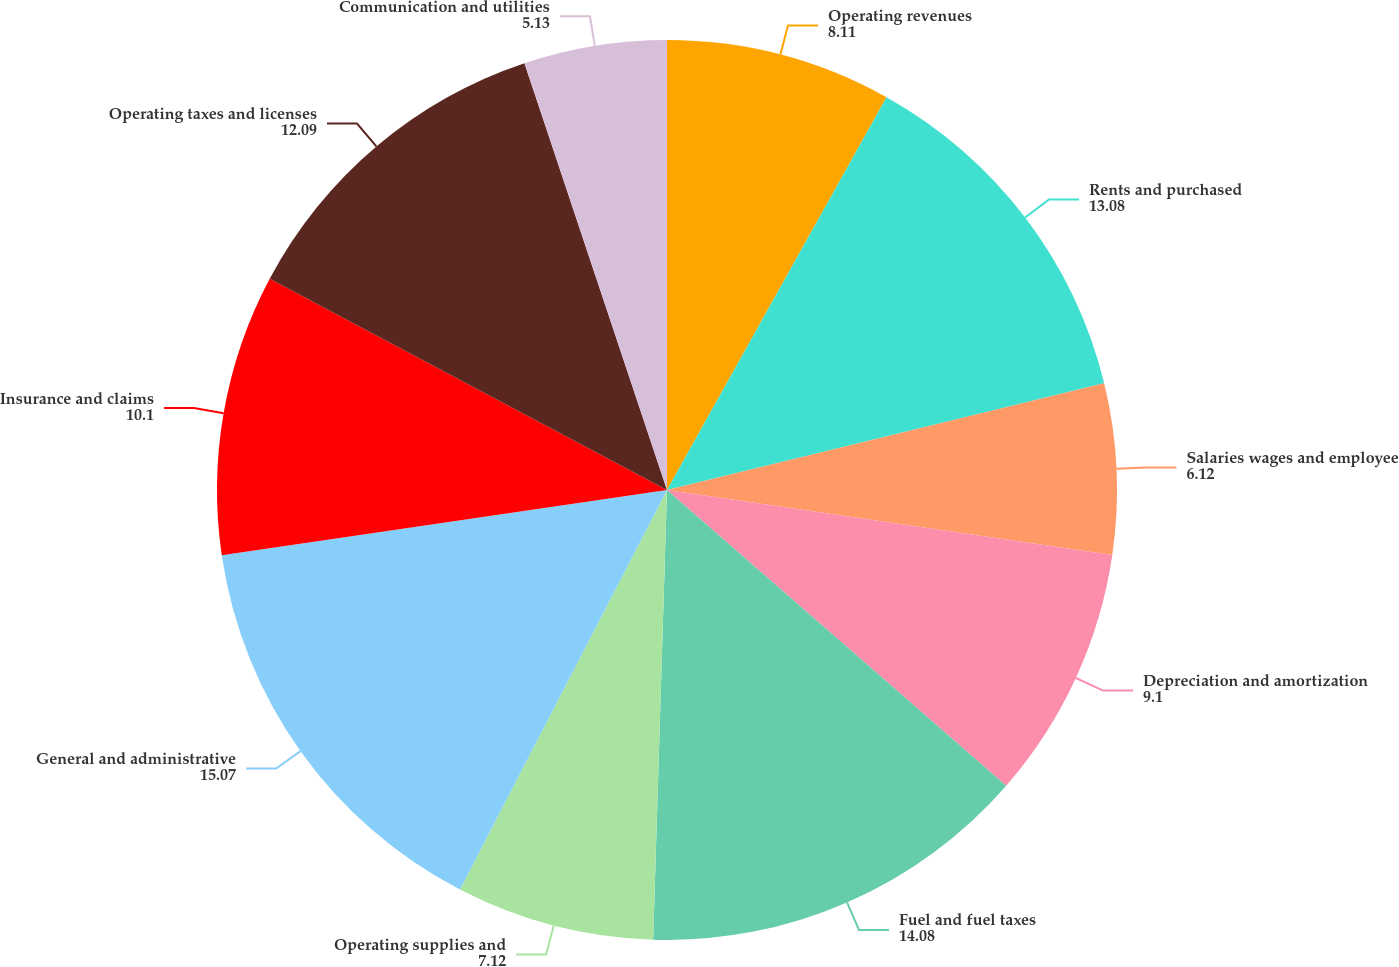<chart> <loc_0><loc_0><loc_500><loc_500><pie_chart><fcel>Operating revenues<fcel>Rents and purchased<fcel>Salaries wages and employee<fcel>Depreciation and amortization<fcel>Fuel and fuel taxes<fcel>Operating supplies and<fcel>General and administrative<fcel>Insurance and claims<fcel>Operating taxes and licenses<fcel>Communication and utilities<nl><fcel>8.11%<fcel>13.08%<fcel>6.12%<fcel>9.1%<fcel>14.08%<fcel>7.12%<fcel>15.07%<fcel>10.1%<fcel>12.09%<fcel>5.13%<nl></chart> 